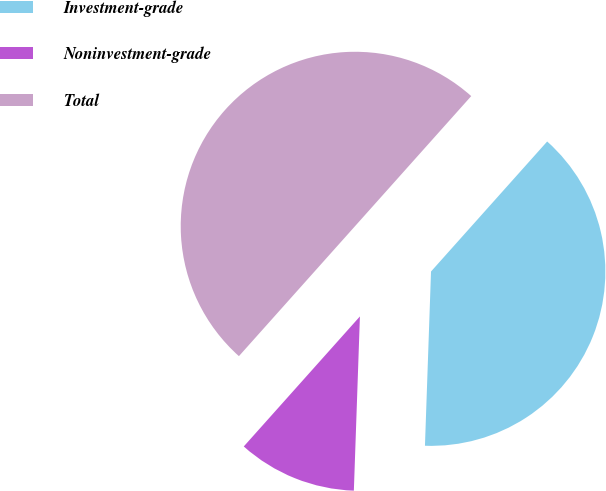Convert chart to OTSL. <chart><loc_0><loc_0><loc_500><loc_500><pie_chart><fcel>Investment-grade<fcel>Noninvestment-grade<fcel>Total<nl><fcel>38.95%<fcel>11.05%<fcel>50.0%<nl></chart> 